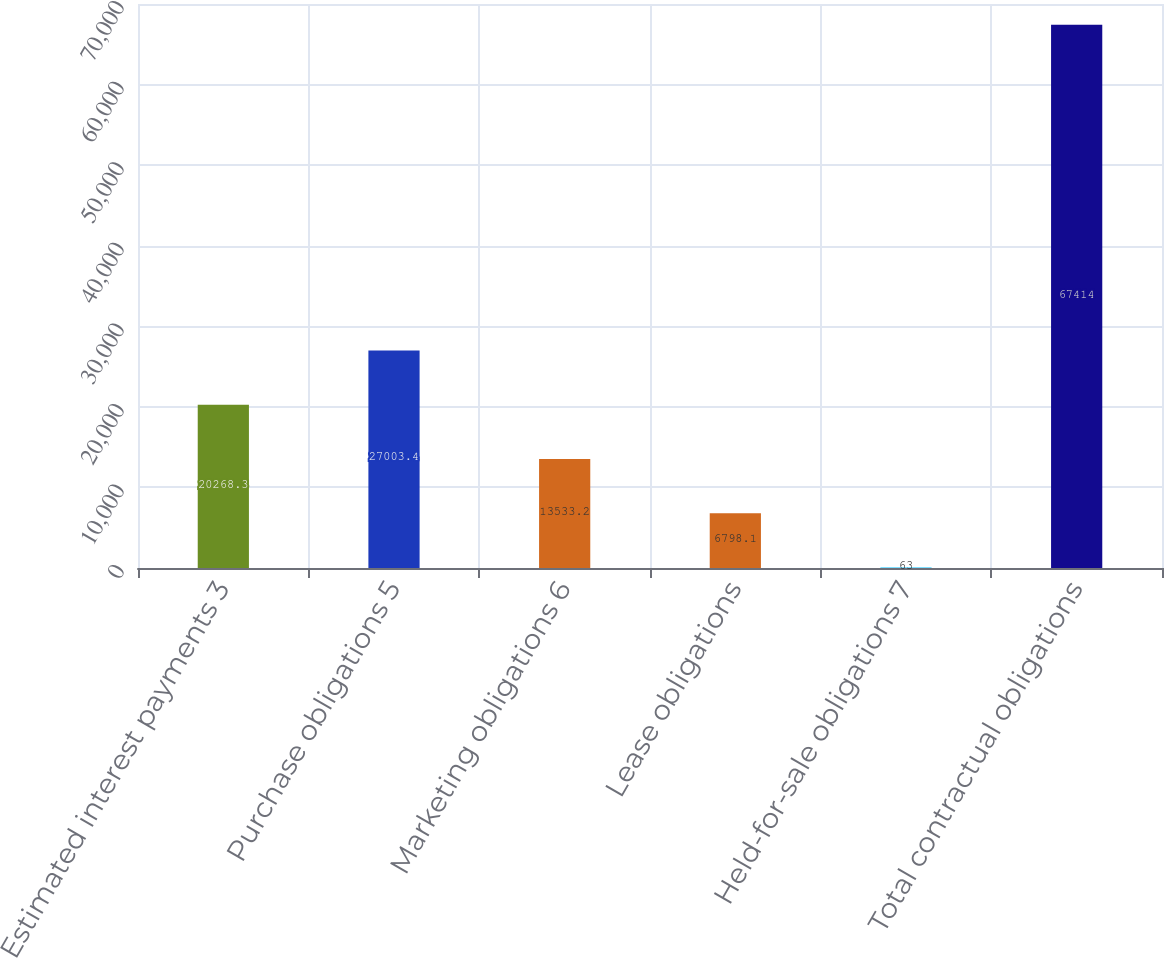<chart> <loc_0><loc_0><loc_500><loc_500><bar_chart><fcel>Estimated interest payments 3<fcel>Purchase obligations 5<fcel>Marketing obligations 6<fcel>Lease obligations<fcel>Held-for-sale obligations 7<fcel>Total contractual obligations<nl><fcel>20268.3<fcel>27003.4<fcel>13533.2<fcel>6798.1<fcel>63<fcel>67414<nl></chart> 